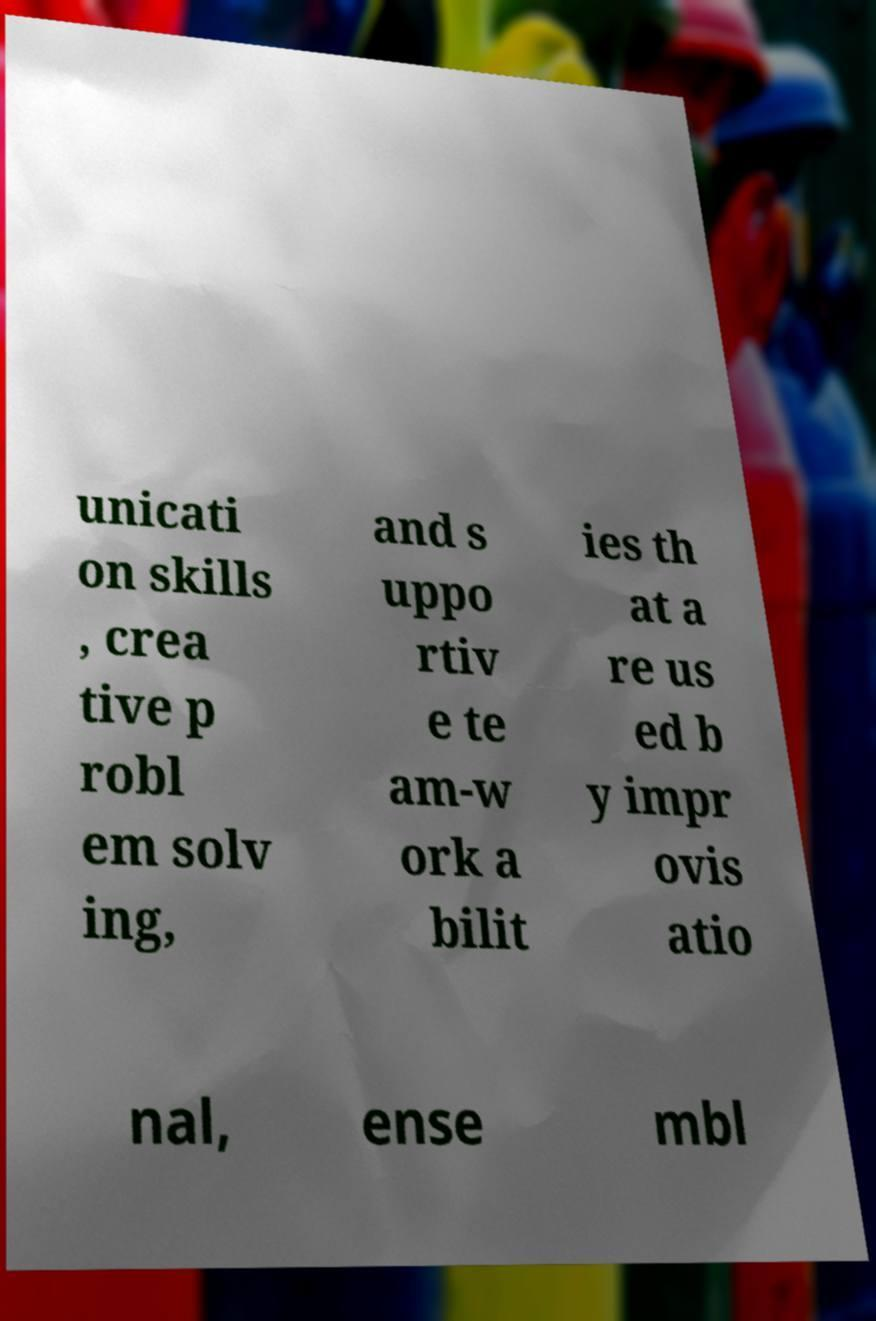For documentation purposes, I need the text within this image transcribed. Could you provide that? unicati on skills , crea tive p robl em solv ing, and s uppo rtiv e te am-w ork a bilit ies th at a re us ed b y impr ovis atio nal, ense mbl 